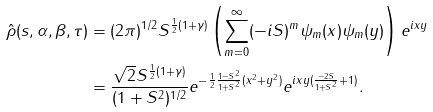Convert formula to latex. <formula><loc_0><loc_0><loc_500><loc_500>\hat { \rho } ( s , \alpha , \beta , \tau ) & = ( 2 \pi ) ^ { 1 / 2 } S ^ { \frac { 1 } { 2 } ( 1 + \gamma ) } \left ( \sum _ { m = 0 } ^ { \infty } ( - i S ) ^ { m } \psi _ { m } ( x ) \psi _ { m } ( y ) \right ) e ^ { i x y } \\ & = \frac { \sqrt { 2 } S ^ { \frac { 1 } { 2 } ( 1 + \gamma ) } } { ( 1 + S ^ { 2 } ) ^ { 1 / 2 } } e ^ { - \frac { 1 } { 2 } \frac { 1 - S ^ { 2 } } { 1 + S ^ { 2 } } ( x ^ { 2 } + y ^ { 2 } ) } e ^ { i x y ( \frac { - 2 S } { 1 + S ^ { 2 } } + 1 ) } .</formula> 